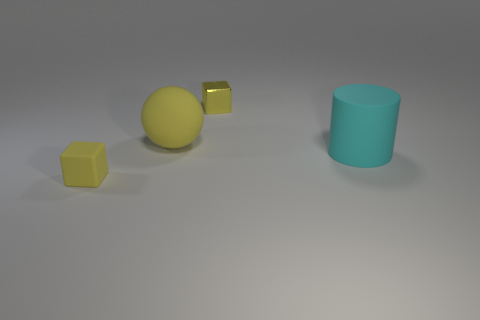Add 1 small purple balls. How many objects exist? 5 Subtract all cylinders. How many objects are left? 3 Subtract 2 blocks. How many blocks are left? 0 Add 4 small yellow shiny cubes. How many small yellow shiny cubes exist? 5 Subtract 0 red cubes. How many objects are left? 4 Subtract all red balls. Subtract all red cylinders. How many balls are left? 1 Subtract all big blue rubber objects. Subtract all matte cylinders. How many objects are left? 3 Add 3 big cyan cylinders. How many big cyan cylinders are left? 4 